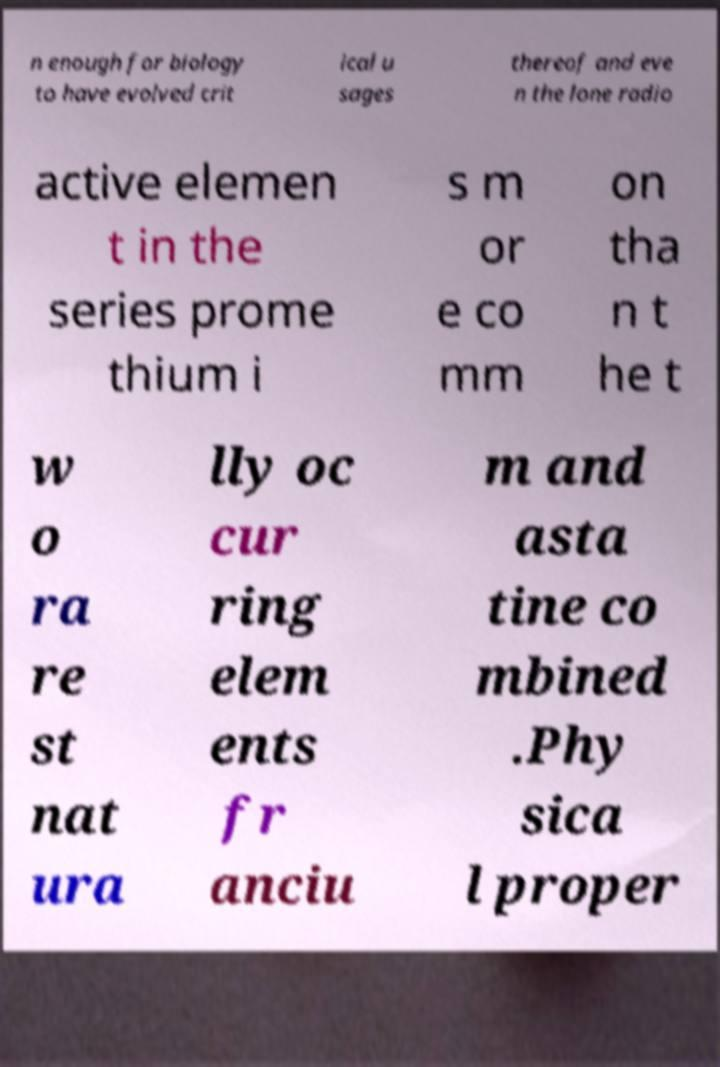Could you assist in decoding the text presented in this image and type it out clearly? n enough for biology to have evolved crit ical u sages thereof and eve n the lone radio active elemen t in the series prome thium i s m or e co mm on tha n t he t w o ra re st nat ura lly oc cur ring elem ents fr anciu m and asta tine co mbined .Phy sica l proper 